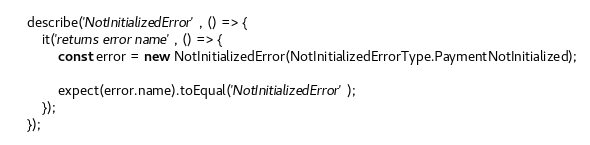Convert code to text. <code><loc_0><loc_0><loc_500><loc_500><_TypeScript_>describe('NotInitializedError', () => {
    it('returns error name', () => {
        const error = new NotInitializedError(NotInitializedErrorType.PaymentNotInitialized);

        expect(error.name).toEqual('NotInitializedError');
    });
});
</code> 